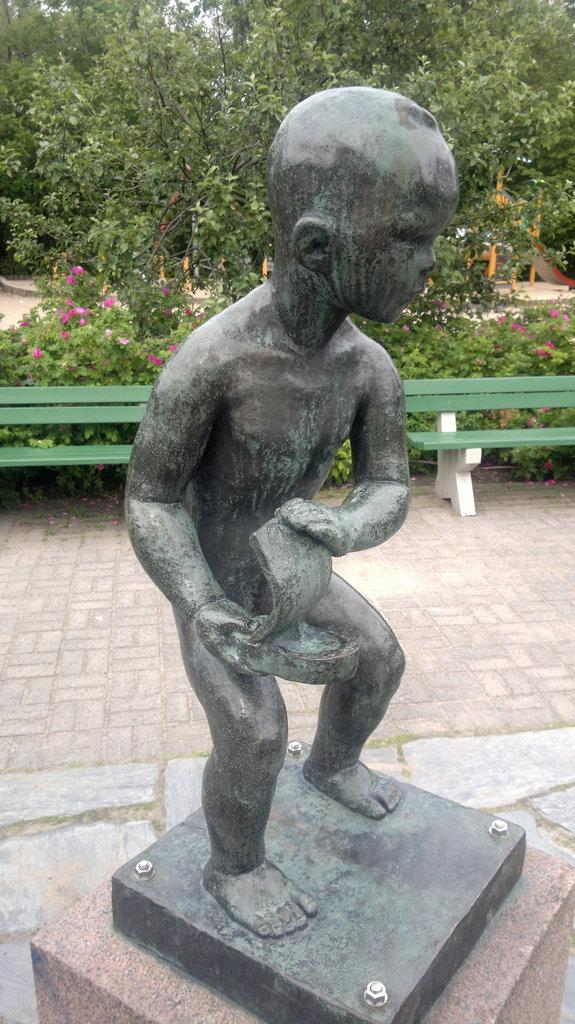What is the main subject of the image? There is a statue of a kid in the image. What is the kid holding in his hand? The kid is holding an object in his hand. What is located behind the statue? There is a bench behind the statue. What type of vegetation can be seen in the image? There are plants and trees in the image. Can you tell me how many giraffes are visible in the image? There are no giraffes present in the image. What color is the crib next to the statue? There is no crib present in the image. 